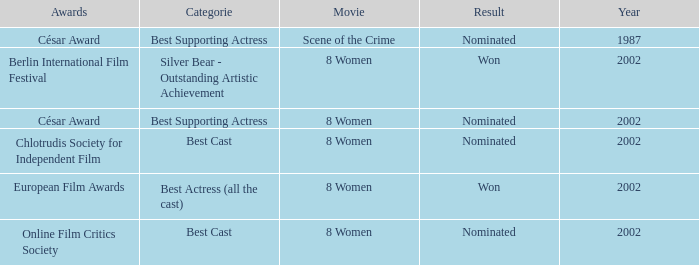What was the categorie in 2002 at the Berlin international Film Festival that Danielle Darrieux was in? Silver Bear - Outstanding Artistic Achievement. 